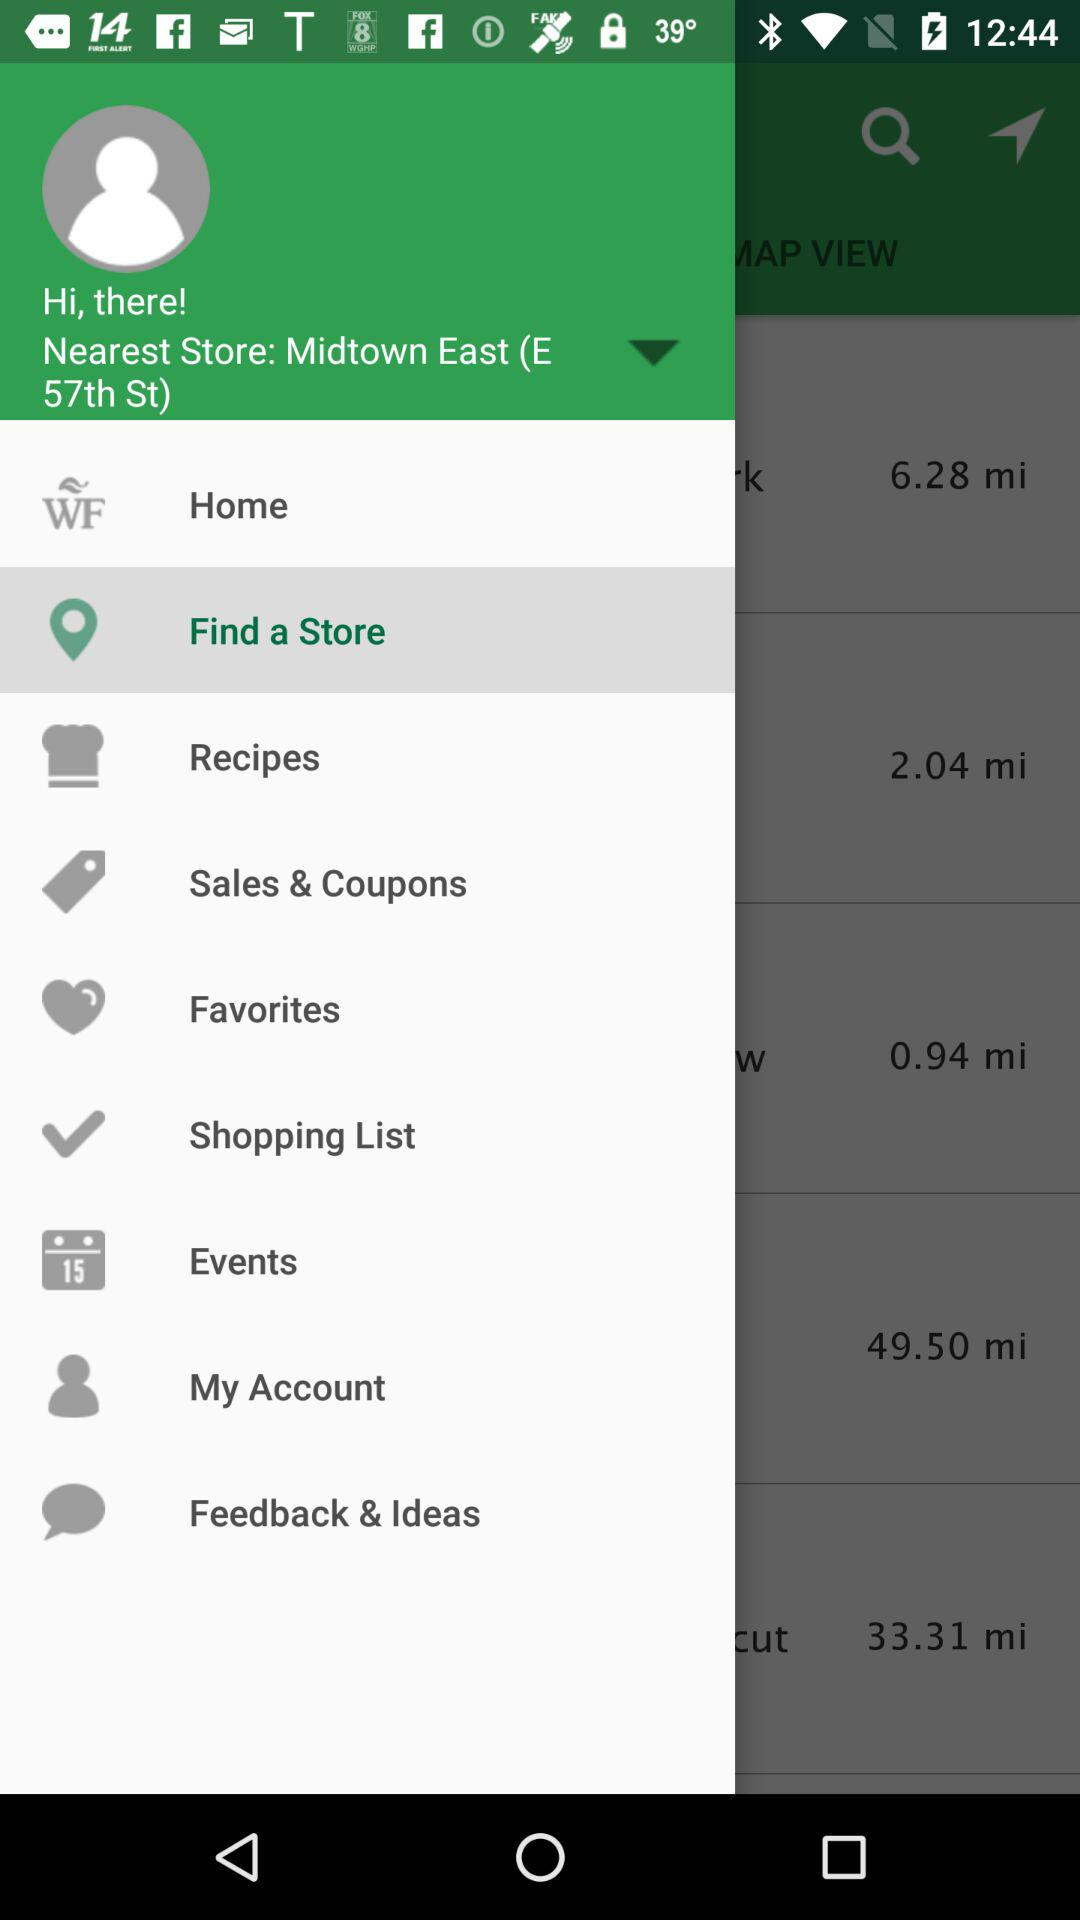Which item is selected? The selected item is "Find a Store". 